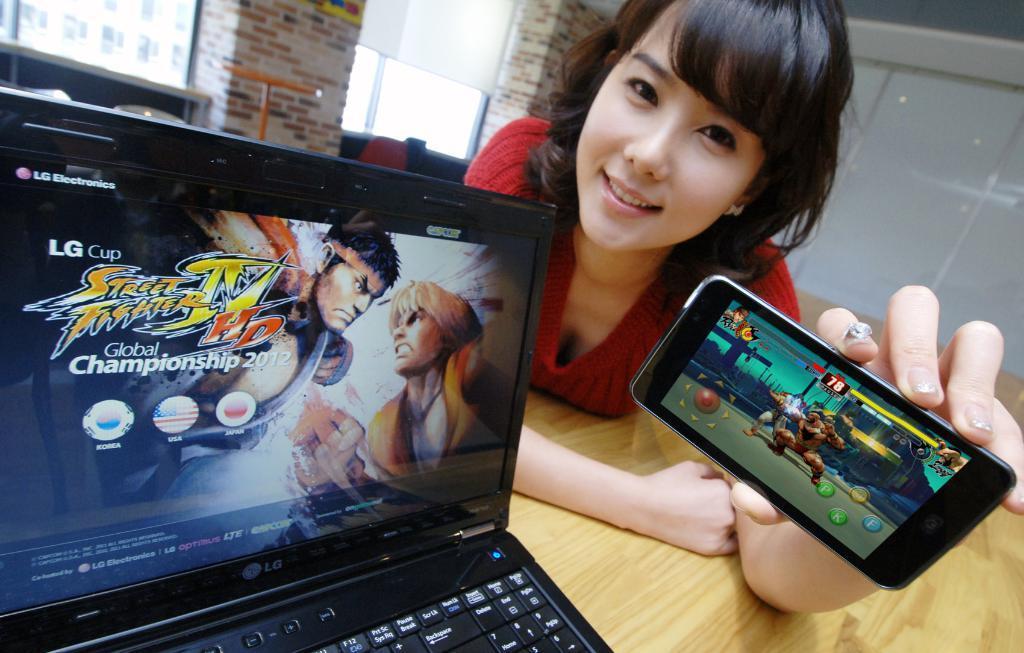Can you describe this image briefly? There is a woman who is holding a mobile with her hand. This is table. On the table there is a laptop. And this is wall. 